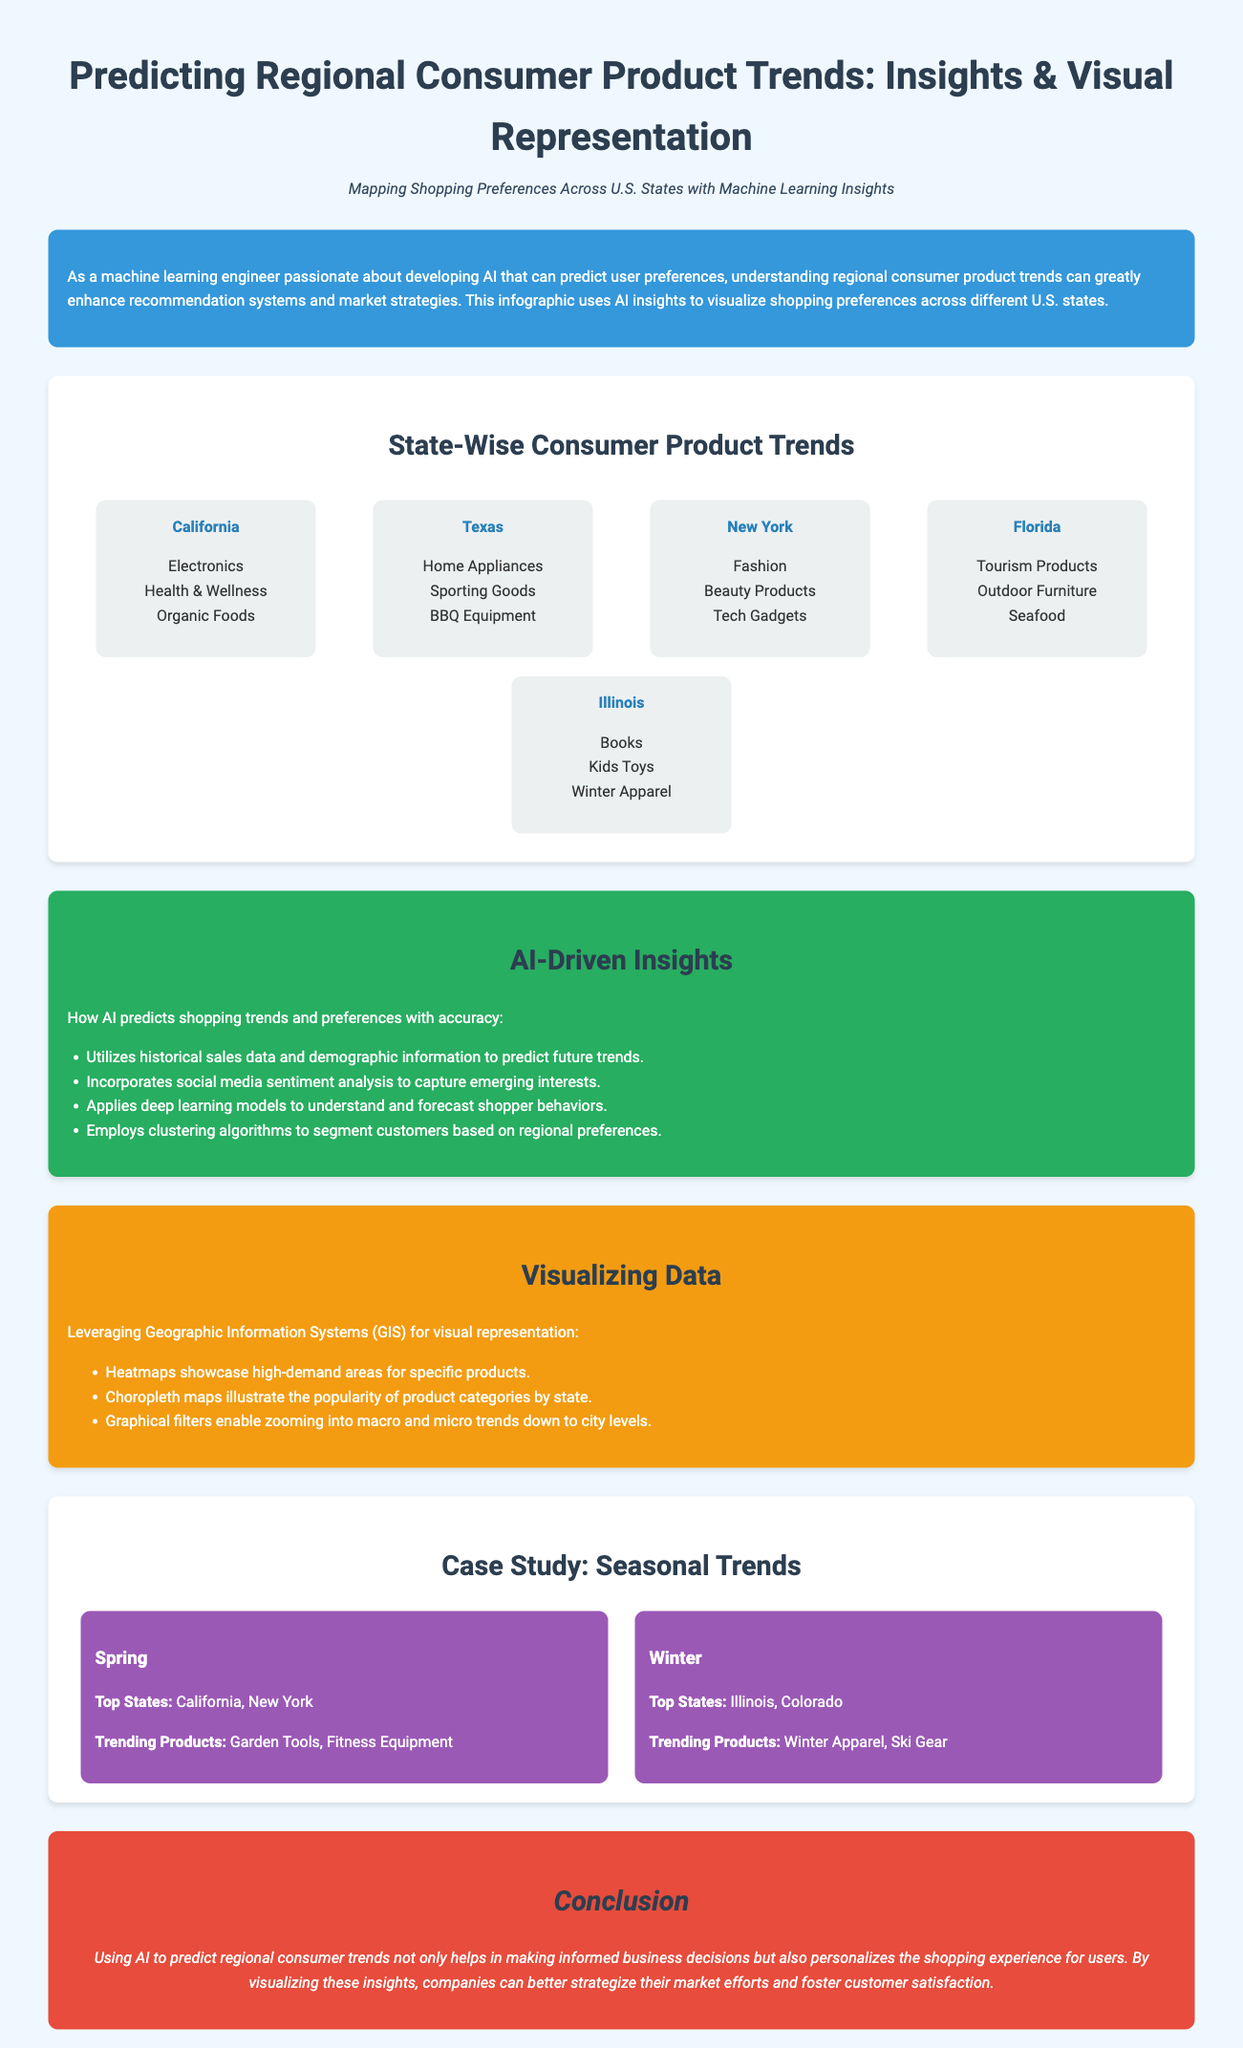What are the top trending products in California? The document lists Electronics, Health & Wellness, and Organic Foods as the top trending products in California.
Answer: Electronics, Health & Wellness, Organic Foods Which state has the highest focus on fashion products? According to the infographic, New York has the highest focus on fashion products.
Answer: New York What seasonal trend is highlighted for Spring? The document indicates that the top states for Spring trends are California and New York, with trending products being Garden Tools and Fitness Equipment.
Answer: California, New York How many AI-driven insights are listed in the section? The section mentions four AI-driven insights regarding shopping trends and preferences.
Answer: Four What color is used for the conclusion section? The infographic specifies that the conclusion section has a background color of red (e74c3c).
Answer: Red Which two states feature prominently for winter trending products? The document mentions Illinois and Colorado as the top states for winter trending products.
Answer: Illinois, Colorado What does AI utilize to predict future trends? The insights state that AI utilizes historical sales data and demographic information to predict future trends.
Answer: Historical sales data, demographic information Which product category is trending in Florida? The document highlights Tourism Products as a trending product category in Florida.
Answer: Tourism Products What type of maps are mentioned for visualizing data? The document references heatmaps and choropleth maps as methods for visualizing data.
Answer: Heatmaps, choropleth maps 